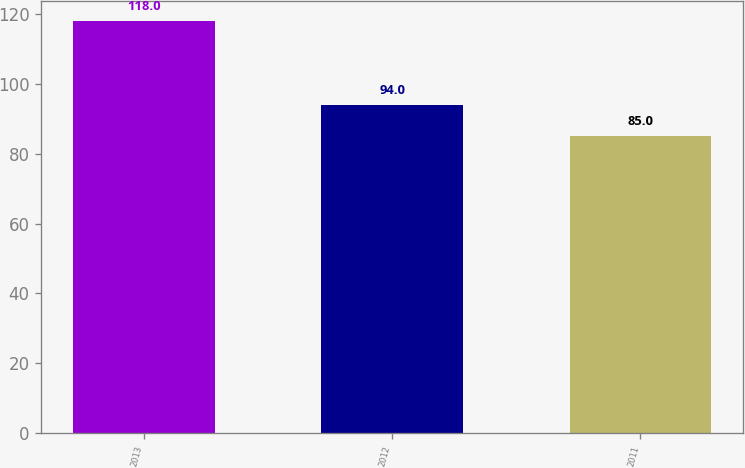Convert chart. <chart><loc_0><loc_0><loc_500><loc_500><bar_chart><fcel>2013<fcel>2012<fcel>2011<nl><fcel>118<fcel>94<fcel>85<nl></chart> 